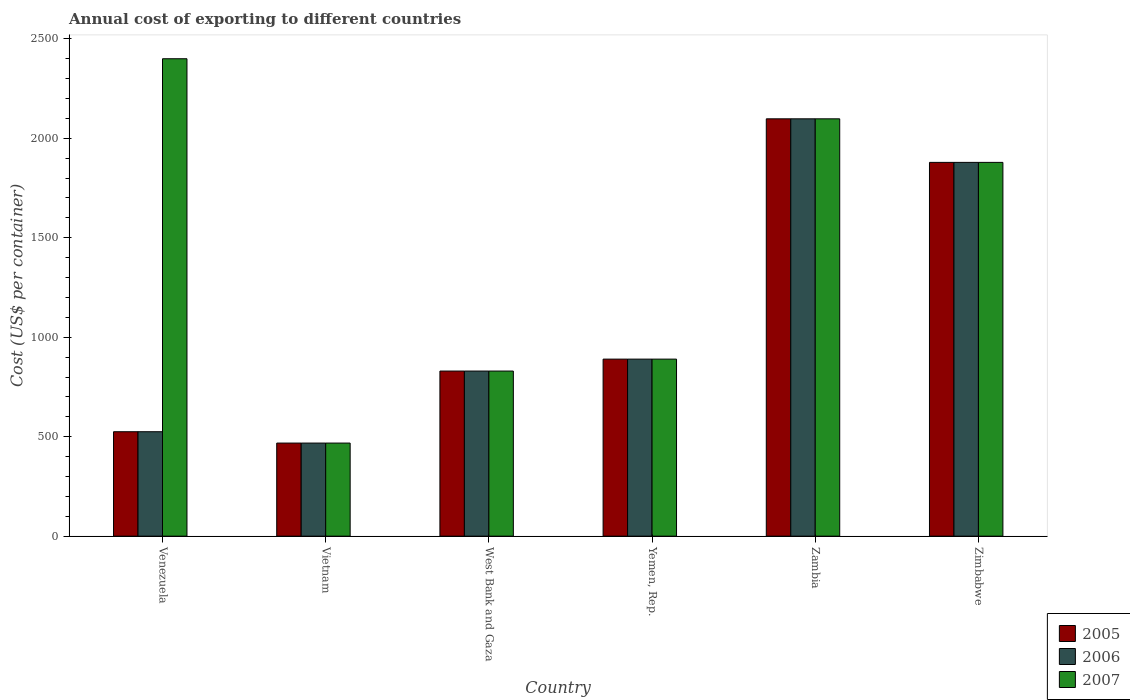How many groups of bars are there?
Offer a very short reply. 6. How many bars are there on the 3rd tick from the left?
Offer a very short reply. 3. What is the label of the 6th group of bars from the left?
Keep it short and to the point. Zimbabwe. In how many cases, is the number of bars for a given country not equal to the number of legend labels?
Keep it short and to the point. 0. What is the total annual cost of exporting in 2007 in Vietnam?
Provide a succinct answer. 468. Across all countries, what is the maximum total annual cost of exporting in 2006?
Ensure brevity in your answer.  2098. Across all countries, what is the minimum total annual cost of exporting in 2006?
Provide a succinct answer. 468. In which country was the total annual cost of exporting in 2006 maximum?
Ensure brevity in your answer.  Zambia. In which country was the total annual cost of exporting in 2005 minimum?
Your answer should be compact. Vietnam. What is the total total annual cost of exporting in 2006 in the graph?
Provide a succinct answer. 6690. What is the difference between the total annual cost of exporting in 2007 in Vietnam and that in West Bank and Gaza?
Your answer should be very brief. -362. What is the difference between the total annual cost of exporting in 2005 in West Bank and Gaza and the total annual cost of exporting in 2007 in Zambia?
Offer a terse response. -1268. What is the average total annual cost of exporting in 2005 per country?
Your answer should be very brief. 1115. What is the difference between the total annual cost of exporting of/in 2005 and total annual cost of exporting of/in 2006 in Zimbabwe?
Make the answer very short. 0. What is the ratio of the total annual cost of exporting in 2006 in West Bank and Gaza to that in Yemen, Rep.?
Keep it short and to the point. 0.93. Is the difference between the total annual cost of exporting in 2005 in Vietnam and West Bank and Gaza greater than the difference between the total annual cost of exporting in 2006 in Vietnam and West Bank and Gaza?
Make the answer very short. No. What is the difference between the highest and the second highest total annual cost of exporting in 2006?
Provide a succinct answer. 1208. What is the difference between the highest and the lowest total annual cost of exporting in 2007?
Offer a terse response. 1932. Is the sum of the total annual cost of exporting in 2006 in Yemen, Rep. and Zimbabwe greater than the maximum total annual cost of exporting in 2007 across all countries?
Provide a short and direct response. Yes. How many bars are there?
Ensure brevity in your answer.  18. Are all the bars in the graph horizontal?
Give a very brief answer. No. How many countries are there in the graph?
Make the answer very short. 6. How many legend labels are there?
Keep it short and to the point. 3. How are the legend labels stacked?
Your answer should be very brief. Vertical. What is the title of the graph?
Provide a short and direct response. Annual cost of exporting to different countries. Does "1992" appear as one of the legend labels in the graph?
Your answer should be compact. No. What is the label or title of the X-axis?
Keep it short and to the point. Country. What is the label or title of the Y-axis?
Offer a very short reply. Cost (US$ per container). What is the Cost (US$ per container) in 2005 in Venezuela?
Provide a succinct answer. 525. What is the Cost (US$ per container) of 2006 in Venezuela?
Provide a succinct answer. 525. What is the Cost (US$ per container) in 2007 in Venezuela?
Provide a short and direct response. 2400. What is the Cost (US$ per container) of 2005 in Vietnam?
Provide a succinct answer. 468. What is the Cost (US$ per container) in 2006 in Vietnam?
Your answer should be compact. 468. What is the Cost (US$ per container) of 2007 in Vietnam?
Your response must be concise. 468. What is the Cost (US$ per container) in 2005 in West Bank and Gaza?
Your response must be concise. 830. What is the Cost (US$ per container) in 2006 in West Bank and Gaza?
Make the answer very short. 830. What is the Cost (US$ per container) of 2007 in West Bank and Gaza?
Provide a succinct answer. 830. What is the Cost (US$ per container) in 2005 in Yemen, Rep.?
Keep it short and to the point. 890. What is the Cost (US$ per container) in 2006 in Yemen, Rep.?
Your answer should be very brief. 890. What is the Cost (US$ per container) of 2007 in Yemen, Rep.?
Your response must be concise. 890. What is the Cost (US$ per container) in 2005 in Zambia?
Make the answer very short. 2098. What is the Cost (US$ per container) in 2006 in Zambia?
Your response must be concise. 2098. What is the Cost (US$ per container) in 2007 in Zambia?
Make the answer very short. 2098. What is the Cost (US$ per container) of 2005 in Zimbabwe?
Offer a terse response. 1879. What is the Cost (US$ per container) in 2006 in Zimbabwe?
Your answer should be very brief. 1879. What is the Cost (US$ per container) in 2007 in Zimbabwe?
Keep it short and to the point. 1879. Across all countries, what is the maximum Cost (US$ per container) in 2005?
Give a very brief answer. 2098. Across all countries, what is the maximum Cost (US$ per container) in 2006?
Provide a succinct answer. 2098. Across all countries, what is the maximum Cost (US$ per container) of 2007?
Make the answer very short. 2400. Across all countries, what is the minimum Cost (US$ per container) in 2005?
Ensure brevity in your answer.  468. Across all countries, what is the minimum Cost (US$ per container) of 2006?
Make the answer very short. 468. Across all countries, what is the minimum Cost (US$ per container) of 2007?
Offer a terse response. 468. What is the total Cost (US$ per container) of 2005 in the graph?
Make the answer very short. 6690. What is the total Cost (US$ per container) of 2006 in the graph?
Your answer should be compact. 6690. What is the total Cost (US$ per container) in 2007 in the graph?
Offer a terse response. 8565. What is the difference between the Cost (US$ per container) of 2006 in Venezuela and that in Vietnam?
Provide a short and direct response. 57. What is the difference between the Cost (US$ per container) of 2007 in Venezuela and that in Vietnam?
Give a very brief answer. 1932. What is the difference between the Cost (US$ per container) of 2005 in Venezuela and that in West Bank and Gaza?
Your answer should be very brief. -305. What is the difference between the Cost (US$ per container) of 2006 in Venezuela and that in West Bank and Gaza?
Keep it short and to the point. -305. What is the difference between the Cost (US$ per container) in 2007 in Venezuela and that in West Bank and Gaza?
Offer a terse response. 1570. What is the difference between the Cost (US$ per container) of 2005 in Venezuela and that in Yemen, Rep.?
Make the answer very short. -365. What is the difference between the Cost (US$ per container) of 2006 in Venezuela and that in Yemen, Rep.?
Provide a succinct answer. -365. What is the difference between the Cost (US$ per container) in 2007 in Venezuela and that in Yemen, Rep.?
Provide a succinct answer. 1510. What is the difference between the Cost (US$ per container) of 2005 in Venezuela and that in Zambia?
Offer a very short reply. -1573. What is the difference between the Cost (US$ per container) of 2006 in Venezuela and that in Zambia?
Offer a very short reply. -1573. What is the difference between the Cost (US$ per container) in 2007 in Venezuela and that in Zambia?
Provide a short and direct response. 302. What is the difference between the Cost (US$ per container) of 2005 in Venezuela and that in Zimbabwe?
Offer a terse response. -1354. What is the difference between the Cost (US$ per container) in 2006 in Venezuela and that in Zimbabwe?
Your answer should be compact. -1354. What is the difference between the Cost (US$ per container) in 2007 in Venezuela and that in Zimbabwe?
Make the answer very short. 521. What is the difference between the Cost (US$ per container) in 2005 in Vietnam and that in West Bank and Gaza?
Provide a short and direct response. -362. What is the difference between the Cost (US$ per container) of 2006 in Vietnam and that in West Bank and Gaza?
Ensure brevity in your answer.  -362. What is the difference between the Cost (US$ per container) of 2007 in Vietnam and that in West Bank and Gaza?
Provide a succinct answer. -362. What is the difference between the Cost (US$ per container) in 2005 in Vietnam and that in Yemen, Rep.?
Offer a very short reply. -422. What is the difference between the Cost (US$ per container) of 2006 in Vietnam and that in Yemen, Rep.?
Your answer should be compact. -422. What is the difference between the Cost (US$ per container) of 2007 in Vietnam and that in Yemen, Rep.?
Offer a very short reply. -422. What is the difference between the Cost (US$ per container) in 2005 in Vietnam and that in Zambia?
Make the answer very short. -1630. What is the difference between the Cost (US$ per container) of 2006 in Vietnam and that in Zambia?
Ensure brevity in your answer.  -1630. What is the difference between the Cost (US$ per container) of 2007 in Vietnam and that in Zambia?
Make the answer very short. -1630. What is the difference between the Cost (US$ per container) in 2005 in Vietnam and that in Zimbabwe?
Your response must be concise. -1411. What is the difference between the Cost (US$ per container) of 2006 in Vietnam and that in Zimbabwe?
Your answer should be very brief. -1411. What is the difference between the Cost (US$ per container) in 2007 in Vietnam and that in Zimbabwe?
Offer a terse response. -1411. What is the difference between the Cost (US$ per container) in 2005 in West Bank and Gaza and that in Yemen, Rep.?
Keep it short and to the point. -60. What is the difference between the Cost (US$ per container) in 2006 in West Bank and Gaza and that in Yemen, Rep.?
Provide a short and direct response. -60. What is the difference between the Cost (US$ per container) in 2007 in West Bank and Gaza and that in Yemen, Rep.?
Provide a succinct answer. -60. What is the difference between the Cost (US$ per container) of 2005 in West Bank and Gaza and that in Zambia?
Offer a very short reply. -1268. What is the difference between the Cost (US$ per container) of 2006 in West Bank and Gaza and that in Zambia?
Give a very brief answer. -1268. What is the difference between the Cost (US$ per container) in 2007 in West Bank and Gaza and that in Zambia?
Provide a succinct answer. -1268. What is the difference between the Cost (US$ per container) in 2005 in West Bank and Gaza and that in Zimbabwe?
Your response must be concise. -1049. What is the difference between the Cost (US$ per container) in 2006 in West Bank and Gaza and that in Zimbabwe?
Your answer should be very brief. -1049. What is the difference between the Cost (US$ per container) of 2007 in West Bank and Gaza and that in Zimbabwe?
Ensure brevity in your answer.  -1049. What is the difference between the Cost (US$ per container) in 2005 in Yemen, Rep. and that in Zambia?
Your response must be concise. -1208. What is the difference between the Cost (US$ per container) in 2006 in Yemen, Rep. and that in Zambia?
Provide a short and direct response. -1208. What is the difference between the Cost (US$ per container) of 2007 in Yemen, Rep. and that in Zambia?
Give a very brief answer. -1208. What is the difference between the Cost (US$ per container) in 2005 in Yemen, Rep. and that in Zimbabwe?
Your answer should be compact. -989. What is the difference between the Cost (US$ per container) in 2006 in Yemen, Rep. and that in Zimbabwe?
Provide a short and direct response. -989. What is the difference between the Cost (US$ per container) in 2007 in Yemen, Rep. and that in Zimbabwe?
Your response must be concise. -989. What is the difference between the Cost (US$ per container) in 2005 in Zambia and that in Zimbabwe?
Your answer should be very brief. 219. What is the difference between the Cost (US$ per container) of 2006 in Zambia and that in Zimbabwe?
Give a very brief answer. 219. What is the difference between the Cost (US$ per container) of 2007 in Zambia and that in Zimbabwe?
Provide a short and direct response. 219. What is the difference between the Cost (US$ per container) in 2005 in Venezuela and the Cost (US$ per container) in 2006 in Vietnam?
Provide a short and direct response. 57. What is the difference between the Cost (US$ per container) in 2005 in Venezuela and the Cost (US$ per container) in 2007 in Vietnam?
Make the answer very short. 57. What is the difference between the Cost (US$ per container) of 2005 in Venezuela and the Cost (US$ per container) of 2006 in West Bank and Gaza?
Your answer should be compact. -305. What is the difference between the Cost (US$ per container) of 2005 in Venezuela and the Cost (US$ per container) of 2007 in West Bank and Gaza?
Ensure brevity in your answer.  -305. What is the difference between the Cost (US$ per container) of 2006 in Venezuela and the Cost (US$ per container) of 2007 in West Bank and Gaza?
Ensure brevity in your answer.  -305. What is the difference between the Cost (US$ per container) in 2005 in Venezuela and the Cost (US$ per container) in 2006 in Yemen, Rep.?
Your answer should be compact. -365. What is the difference between the Cost (US$ per container) of 2005 in Venezuela and the Cost (US$ per container) of 2007 in Yemen, Rep.?
Provide a succinct answer. -365. What is the difference between the Cost (US$ per container) in 2006 in Venezuela and the Cost (US$ per container) in 2007 in Yemen, Rep.?
Provide a succinct answer. -365. What is the difference between the Cost (US$ per container) in 2005 in Venezuela and the Cost (US$ per container) in 2006 in Zambia?
Ensure brevity in your answer.  -1573. What is the difference between the Cost (US$ per container) of 2005 in Venezuela and the Cost (US$ per container) of 2007 in Zambia?
Your answer should be very brief. -1573. What is the difference between the Cost (US$ per container) in 2006 in Venezuela and the Cost (US$ per container) in 2007 in Zambia?
Make the answer very short. -1573. What is the difference between the Cost (US$ per container) of 2005 in Venezuela and the Cost (US$ per container) of 2006 in Zimbabwe?
Provide a short and direct response. -1354. What is the difference between the Cost (US$ per container) of 2005 in Venezuela and the Cost (US$ per container) of 2007 in Zimbabwe?
Offer a terse response. -1354. What is the difference between the Cost (US$ per container) in 2006 in Venezuela and the Cost (US$ per container) in 2007 in Zimbabwe?
Your answer should be compact. -1354. What is the difference between the Cost (US$ per container) in 2005 in Vietnam and the Cost (US$ per container) in 2006 in West Bank and Gaza?
Give a very brief answer. -362. What is the difference between the Cost (US$ per container) in 2005 in Vietnam and the Cost (US$ per container) in 2007 in West Bank and Gaza?
Keep it short and to the point. -362. What is the difference between the Cost (US$ per container) of 2006 in Vietnam and the Cost (US$ per container) of 2007 in West Bank and Gaza?
Provide a short and direct response. -362. What is the difference between the Cost (US$ per container) in 2005 in Vietnam and the Cost (US$ per container) in 2006 in Yemen, Rep.?
Make the answer very short. -422. What is the difference between the Cost (US$ per container) of 2005 in Vietnam and the Cost (US$ per container) of 2007 in Yemen, Rep.?
Provide a short and direct response. -422. What is the difference between the Cost (US$ per container) in 2006 in Vietnam and the Cost (US$ per container) in 2007 in Yemen, Rep.?
Ensure brevity in your answer.  -422. What is the difference between the Cost (US$ per container) in 2005 in Vietnam and the Cost (US$ per container) in 2006 in Zambia?
Provide a succinct answer. -1630. What is the difference between the Cost (US$ per container) in 2005 in Vietnam and the Cost (US$ per container) in 2007 in Zambia?
Give a very brief answer. -1630. What is the difference between the Cost (US$ per container) in 2006 in Vietnam and the Cost (US$ per container) in 2007 in Zambia?
Your answer should be very brief. -1630. What is the difference between the Cost (US$ per container) in 2005 in Vietnam and the Cost (US$ per container) in 2006 in Zimbabwe?
Your answer should be very brief. -1411. What is the difference between the Cost (US$ per container) in 2005 in Vietnam and the Cost (US$ per container) in 2007 in Zimbabwe?
Give a very brief answer. -1411. What is the difference between the Cost (US$ per container) in 2006 in Vietnam and the Cost (US$ per container) in 2007 in Zimbabwe?
Your response must be concise. -1411. What is the difference between the Cost (US$ per container) in 2005 in West Bank and Gaza and the Cost (US$ per container) in 2006 in Yemen, Rep.?
Provide a succinct answer. -60. What is the difference between the Cost (US$ per container) of 2005 in West Bank and Gaza and the Cost (US$ per container) of 2007 in Yemen, Rep.?
Your answer should be compact. -60. What is the difference between the Cost (US$ per container) of 2006 in West Bank and Gaza and the Cost (US$ per container) of 2007 in Yemen, Rep.?
Offer a very short reply. -60. What is the difference between the Cost (US$ per container) of 2005 in West Bank and Gaza and the Cost (US$ per container) of 2006 in Zambia?
Offer a terse response. -1268. What is the difference between the Cost (US$ per container) of 2005 in West Bank and Gaza and the Cost (US$ per container) of 2007 in Zambia?
Provide a succinct answer. -1268. What is the difference between the Cost (US$ per container) in 2006 in West Bank and Gaza and the Cost (US$ per container) in 2007 in Zambia?
Your answer should be very brief. -1268. What is the difference between the Cost (US$ per container) in 2005 in West Bank and Gaza and the Cost (US$ per container) in 2006 in Zimbabwe?
Make the answer very short. -1049. What is the difference between the Cost (US$ per container) in 2005 in West Bank and Gaza and the Cost (US$ per container) in 2007 in Zimbabwe?
Your response must be concise. -1049. What is the difference between the Cost (US$ per container) in 2006 in West Bank and Gaza and the Cost (US$ per container) in 2007 in Zimbabwe?
Offer a terse response. -1049. What is the difference between the Cost (US$ per container) of 2005 in Yemen, Rep. and the Cost (US$ per container) of 2006 in Zambia?
Make the answer very short. -1208. What is the difference between the Cost (US$ per container) of 2005 in Yemen, Rep. and the Cost (US$ per container) of 2007 in Zambia?
Your answer should be compact. -1208. What is the difference between the Cost (US$ per container) of 2006 in Yemen, Rep. and the Cost (US$ per container) of 2007 in Zambia?
Your answer should be very brief. -1208. What is the difference between the Cost (US$ per container) of 2005 in Yemen, Rep. and the Cost (US$ per container) of 2006 in Zimbabwe?
Give a very brief answer. -989. What is the difference between the Cost (US$ per container) of 2005 in Yemen, Rep. and the Cost (US$ per container) of 2007 in Zimbabwe?
Offer a terse response. -989. What is the difference between the Cost (US$ per container) in 2006 in Yemen, Rep. and the Cost (US$ per container) in 2007 in Zimbabwe?
Ensure brevity in your answer.  -989. What is the difference between the Cost (US$ per container) of 2005 in Zambia and the Cost (US$ per container) of 2006 in Zimbabwe?
Provide a short and direct response. 219. What is the difference between the Cost (US$ per container) in 2005 in Zambia and the Cost (US$ per container) in 2007 in Zimbabwe?
Make the answer very short. 219. What is the difference between the Cost (US$ per container) of 2006 in Zambia and the Cost (US$ per container) of 2007 in Zimbabwe?
Your answer should be compact. 219. What is the average Cost (US$ per container) in 2005 per country?
Ensure brevity in your answer.  1115. What is the average Cost (US$ per container) of 2006 per country?
Your answer should be compact. 1115. What is the average Cost (US$ per container) in 2007 per country?
Ensure brevity in your answer.  1427.5. What is the difference between the Cost (US$ per container) of 2005 and Cost (US$ per container) of 2006 in Venezuela?
Your answer should be very brief. 0. What is the difference between the Cost (US$ per container) in 2005 and Cost (US$ per container) in 2007 in Venezuela?
Give a very brief answer. -1875. What is the difference between the Cost (US$ per container) in 2006 and Cost (US$ per container) in 2007 in Venezuela?
Offer a very short reply. -1875. What is the difference between the Cost (US$ per container) in 2005 and Cost (US$ per container) in 2006 in Vietnam?
Offer a very short reply. 0. What is the difference between the Cost (US$ per container) in 2005 and Cost (US$ per container) in 2007 in West Bank and Gaza?
Offer a terse response. 0. What is the difference between the Cost (US$ per container) of 2005 and Cost (US$ per container) of 2007 in Yemen, Rep.?
Give a very brief answer. 0. What is the difference between the Cost (US$ per container) in 2005 and Cost (US$ per container) in 2006 in Zambia?
Make the answer very short. 0. What is the difference between the Cost (US$ per container) of 2006 and Cost (US$ per container) of 2007 in Zambia?
Your response must be concise. 0. What is the difference between the Cost (US$ per container) in 2005 and Cost (US$ per container) in 2006 in Zimbabwe?
Provide a short and direct response. 0. What is the difference between the Cost (US$ per container) of 2006 and Cost (US$ per container) of 2007 in Zimbabwe?
Provide a succinct answer. 0. What is the ratio of the Cost (US$ per container) of 2005 in Venezuela to that in Vietnam?
Provide a succinct answer. 1.12. What is the ratio of the Cost (US$ per container) of 2006 in Venezuela to that in Vietnam?
Give a very brief answer. 1.12. What is the ratio of the Cost (US$ per container) of 2007 in Venezuela to that in Vietnam?
Ensure brevity in your answer.  5.13. What is the ratio of the Cost (US$ per container) in 2005 in Venezuela to that in West Bank and Gaza?
Provide a succinct answer. 0.63. What is the ratio of the Cost (US$ per container) in 2006 in Venezuela to that in West Bank and Gaza?
Provide a short and direct response. 0.63. What is the ratio of the Cost (US$ per container) of 2007 in Venezuela to that in West Bank and Gaza?
Make the answer very short. 2.89. What is the ratio of the Cost (US$ per container) in 2005 in Venezuela to that in Yemen, Rep.?
Offer a terse response. 0.59. What is the ratio of the Cost (US$ per container) in 2006 in Venezuela to that in Yemen, Rep.?
Ensure brevity in your answer.  0.59. What is the ratio of the Cost (US$ per container) in 2007 in Venezuela to that in Yemen, Rep.?
Your answer should be compact. 2.7. What is the ratio of the Cost (US$ per container) in 2005 in Venezuela to that in Zambia?
Offer a terse response. 0.25. What is the ratio of the Cost (US$ per container) of 2006 in Venezuela to that in Zambia?
Keep it short and to the point. 0.25. What is the ratio of the Cost (US$ per container) of 2007 in Venezuela to that in Zambia?
Give a very brief answer. 1.14. What is the ratio of the Cost (US$ per container) in 2005 in Venezuela to that in Zimbabwe?
Provide a short and direct response. 0.28. What is the ratio of the Cost (US$ per container) of 2006 in Venezuela to that in Zimbabwe?
Your answer should be very brief. 0.28. What is the ratio of the Cost (US$ per container) in 2007 in Venezuela to that in Zimbabwe?
Your response must be concise. 1.28. What is the ratio of the Cost (US$ per container) of 2005 in Vietnam to that in West Bank and Gaza?
Make the answer very short. 0.56. What is the ratio of the Cost (US$ per container) in 2006 in Vietnam to that in West Bank and Gaza?
Keep it short and to the point. 0.56. What is the ratio of the Cost (US$ per container) in 2007 in Vietnam to that in West Bank and Gaza?
Keep it short and to the point. 0.56. What is the ratio of the Cost (US$ per container) in 2005 in Vietnam to that in Yemen, Rep.?
Your answer should be compact. 0.53. What is the ratio of the Cost (US$ per container) in 2006 in Vietnam to that in Yemen, Rep.?
Keep it short and to the point. 0.53. What is the ratio of the Cost (US$ per container) in 2007 in Vietnam to that in Yemen, Rep.?
Ensure brevity in your answer.  0.53. What is the ratio of the Cost (US$ per container) in 2005 in Vietnam to that in Zambia?
Your answer should be very brief. 0.22. What is the ratio of the Cost (US$ per container) of 2006 in Vietnam to that in Zambia?
Provide a short and direct response. 0.22. What is the ratio of the Cost (US$ per container) in 2007 in Vietnam to that in Zambia?
Give a very brief answer. 0.22. What is the ratio of the Cost (US$ per container) of 2005 in Vietnam to that in Zimbabwe?
Your answer should be compact. 0.25. What is the ratio of the Cost (US$ per container) in 2006 in Vietnam to that in Zimbabwe?
Make the answer very short. 0.25. What is the ratio of the Cost (US$ per container) in 2007 in Vietnam to that in Zimbabwe?
Your answer should be compact. 0.25. What is the ratio of the Cost (US$ per container) of 2005 in West Bank and Gaza to that in Yemen, Rep.?
Make the answer very short. 0.93. What is the ratio of the Cost (US$ per container) in 2006 in West Bank and Gaza to that in Yemen, Rep.?
Offer a very short reply. 0.93. What is the ratio of the Cost (US$ per container) in 2007 in West Bank and Gaza to that in Yemen, Rep.?
Keep it short and to the point. 0.93. What is the ratio of the Cost (US$ per container) in 2005 in West Bank and Gaza to that in Zambia?
Provide a succinct answer. 0.4. What is the ratio of the Cost (US$ per container) in 2006 in West Bank and Gaza to that in Zambia?
Make the answer very short. 0.4. What is the ratio of the Cost (US$ per container) in 2007 in West Bank and Gaza to that in Zambia?
Your response must be concise. 0.4. What is the ratio of the Cost (US$ per container) in 2005 in West Bank and Gaza to that in Zimbabwe?
Provide a short and direct response. 0.44. What is the ratio of the Cost (US$ per container) of 2006 in West Bank and Gaza to that in Zimbabwe?
Your answer should be compact. 0.44. What is the ratio of the Cost (US$ per container) of 2007 in West Bank and Gaza to that in Zimbabwe?
Provide a succinct answer. 0.44. What is the ratio of the Cost (US$ per container) of 2005 in Yemen, Rep. to that in Zambia?
Your answer should be compact. 0.42. What is the ratio of the Cost (US$ per container) in 2006 in Yemen, Rep. to that in Zambia?
Your answer should be compact. 0.42. What is the ratio of the Cost (US$ per container) in 2007 in Yemen, Rep. to that in Zambia?
Keep it short and to the point. 0.42. What is the ratio of the Cost (US$ per container) of 2005 in Yemen, Rep. to that in Zimbabwe?
Make the answer very short. 0.47. What is the ratio of the Cost (US$ per container) of 2006 in Yemen, Rep. to that in Zimbabwe?
Provide a succinct answer. 0.47. What is the ratio of the Cost (US$ per container) in 2007 in Yemen, Rep. to that in Zimbabwe?
Provide a succinct answer. 0.47. What is the ratio of the Cost (US$ per container) of 2005 in Zambia to that in Zimbabwe?
Keep it short and to the point. 1.12. What is the ratio of the Cost (US$ per container) of 2006 in Zambia to that in Zimbabwe?
Your response must be concise. 1.12. What is the ratio of the Cost (US$ per container) in 2007 in Zambia to that in Zimbabwe?
Make the answer very short. 1.12. What is the difference between the highest and the second highest Cost (US$ per container) of 2005?
Give a very brief answer. 219. What is the difference between the highest and the second highest Cost (US$ per container) of 2006?
Offer a very short reply. 219. What is the difference between the highest and the second highest Cost (US$ per container) in 2007?
Your response must be concise. 302. What is the difference between the highest and the lowest Cost (US$ per container) in 2005?
Offer a very short reply. 1630. What is the difference between the highest and the lowest Cost (US$ per container) of 2006?
Provide a short and direct response. 1630. What is the difference between the highest and the lowest Cost (US$ per container) of 2007?
Your answer should be compact. 1932. 